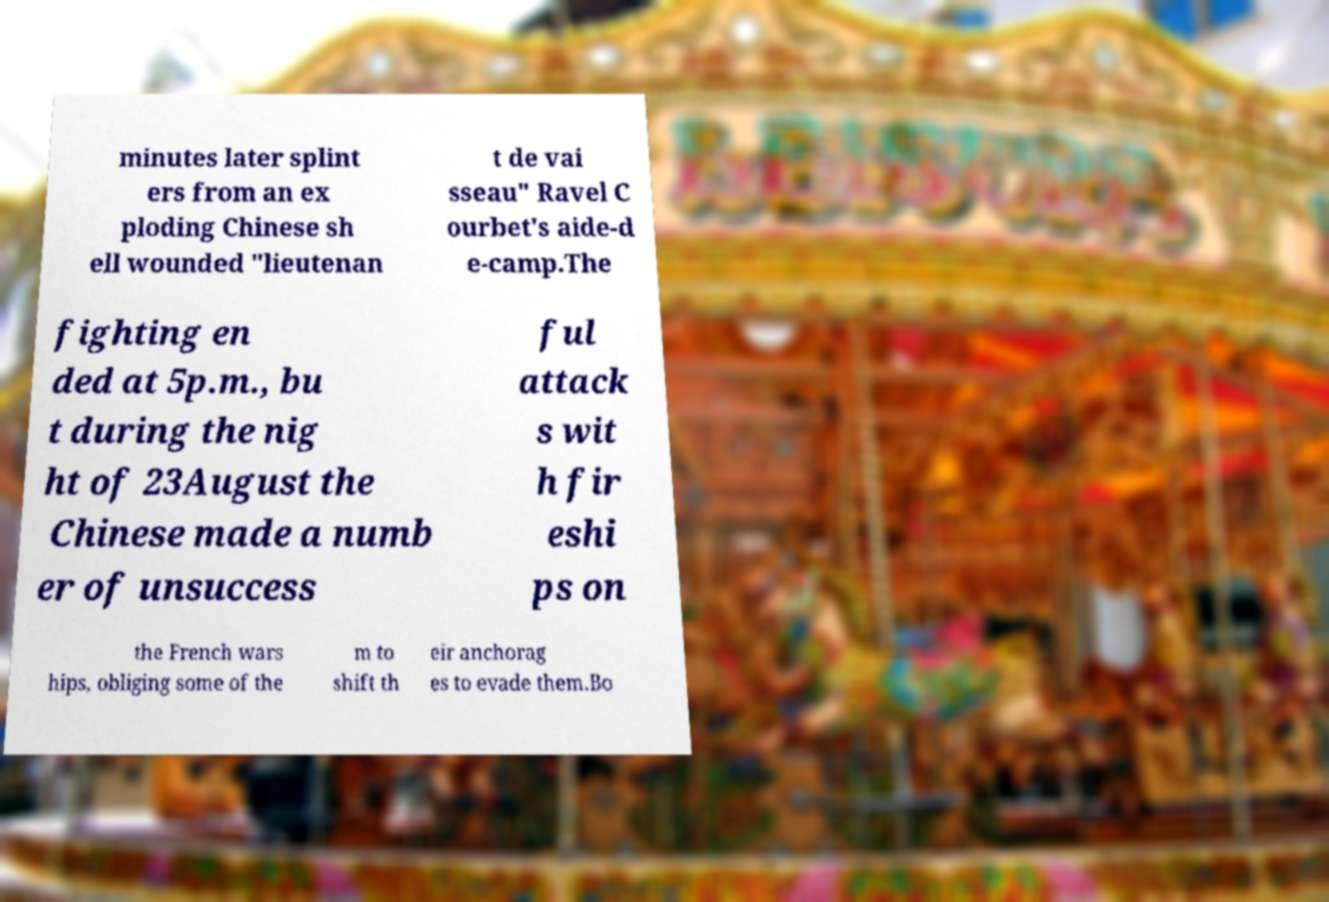Please identify and transcribe the text found in this image. minutes later splint ers from an ex ploding Chinese sh ell wounded "lieutenan t de vai sseau" Ravel C ourbet's aide-d e-camp.The fighting en ded at 5p.m., bu t during the nig ht of 23August the Chinese made a numb er of unsuccess ful attack s wit h fir eshi ps on the French wars hips, obliging some of the m to shift th eir anchorag es to evade them.Bo 